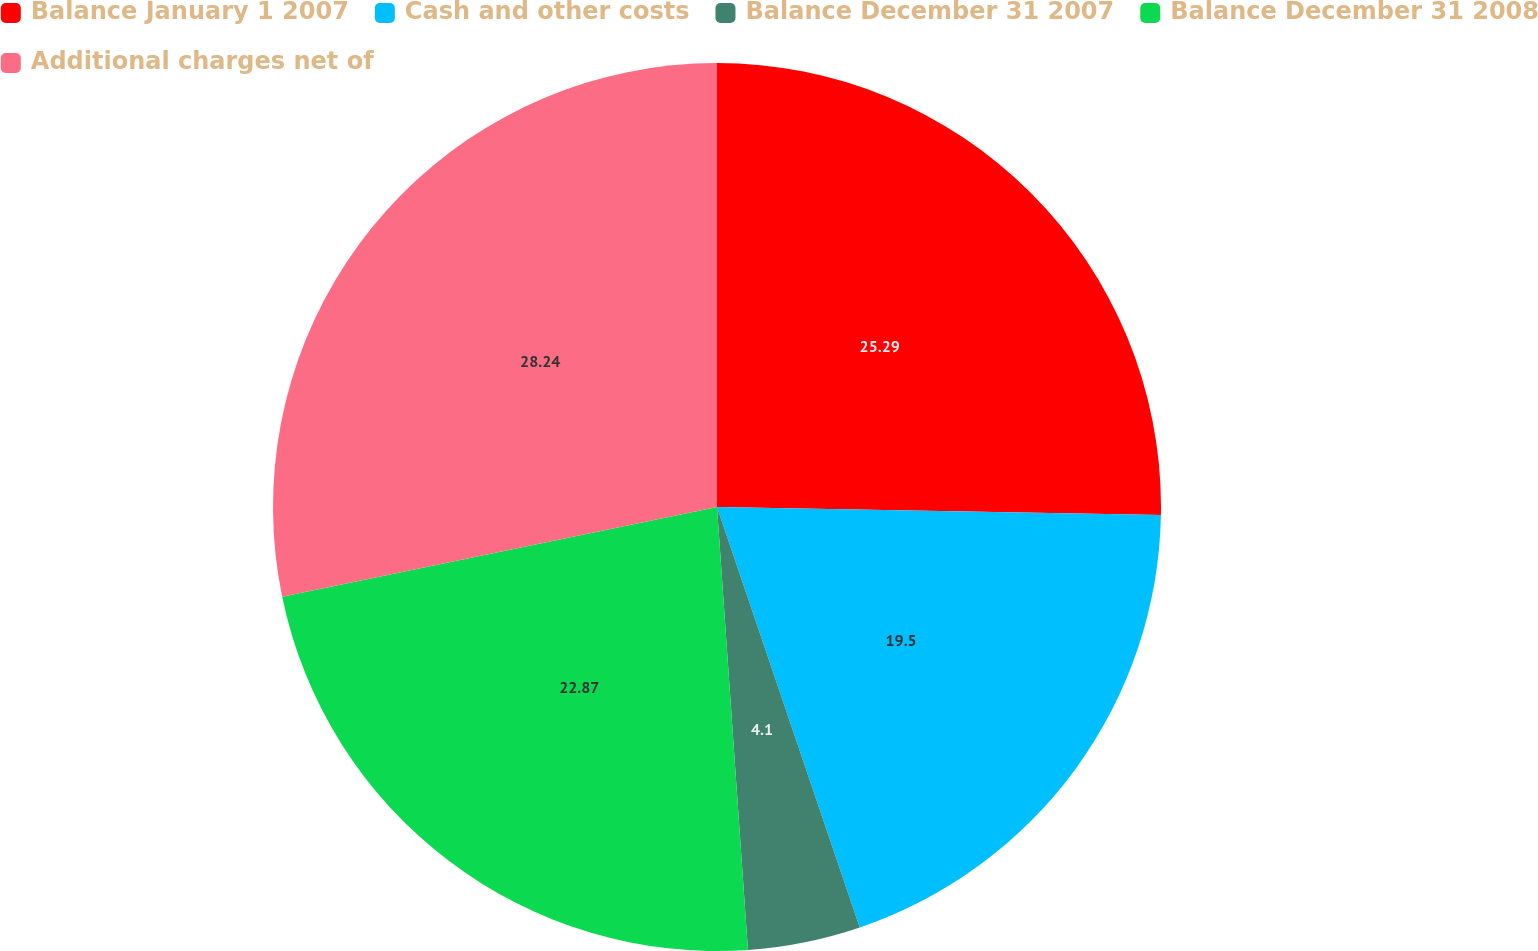<chart> <loc_0><loc_0><loc_500><loc_500><pie_chart><fcel>Balance January 1 2007<fcel>Cash and other costs<fcel>Balance December 31 2007<fcel>Balance December 31 2008<fcel>Additional charges net of<nl><fcel>25.29%<fcel>19.5%<fcel>4.1%<fcel>22.87%<fcel>28.24%<nl></chart> 